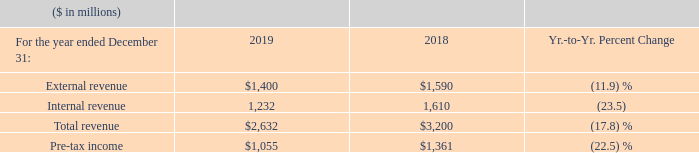In 2019, Global Financing delivered external revenue of $1,400 million and total revenue of $2,632 million, with a decrease in gross margin of 2.7 points to 58.8 percent. Total pre-tax income of $1,055 million decreased 22.5 percent compared to 2018 and return on equity decreased 5.0 points to 25.8 percent.
Global Financing total revenue decreased 17.8 percent compared to the prior year. This was due to a decrease in internal revenue of 23.5 percent, driven by decreases in internal used equipment sales (down 27.4 percent to $862 million) and internal financing (down 12.6 percent to $370 million). External revenue declined 11.9 percent due to decreases in external financing (down 8.5 percent to $1,120 million) and external used equipment sales (down 23.4 percent to $281 million).
The decrease in internal financing revenue was due to lower average asset balances, partially offset by higher asset yields. The decrease in external financing revenue reflects the wind down of the OEM IT commercial financing operations.
Sales of used equipment represented 43.4 percent and 48.5 percent of Global Financing’s revenue for the years ended December 31, 2019 and 2018, respectively. The decrease in 2019 was due to a lower volume of internal used equipment sales. The gross profit margin on used sales was 52.2 percent and 54.2 percent for the years ended December 31, 2019 and 2018, respectively. The decrease in the gross profit margin was driven by lower margins on internal used equipment sales.
Global Financing pre-tax income decreased 22.5 percent year to year primarily driven by a decrease in gross profit ($422 million), partially offset by a decrease in total expense ($115 million), which was mainly driven by a decline in IBM shared expenses in line with the segment’s performance, a lower provision for credit losses and a gain from the sale of certain commercial financing capabilities in the first quarter of 2019.
The decrease in return on equity from 2018 to 2019 was primarily due to lower net income. Refer to page 45 for the details of the after-tax income and return on equity calculations.
What caused the Global Financing total revenue to decrease? This was due to a decrease in internal revenue of 23.5 percent, driven by decreases in internal used equipment sales (down 27.4 percent to $862 million) and internal financing (down 12.6 percent to $370 million). What caused the internal financing revenue to decrease? The decrease in internal financing revenue was due to lower average asset balances, partially offset by higher asset yields. the decrease in external financing revenue reflects the wind down of the oem it commercial financing operations. What caused the sales of used equipment to decrease? The decrease in 2019 was due to a lower volume of internal used equipment sales. What is the average External revenue?
Answer scale should be: million. (1,400 + 1,590) / 2
Answer: 1495. What is the increase / (decrease) in the internal revenue from 2018 to 2019?
Answer scale should be: million. 1,232 - 1,610
Answer: -378. What percentage of total revenue is Pre-tax income in 2019?
Answer scale should be: percent. 1,055 / 2,632
Answer: 40.08. 